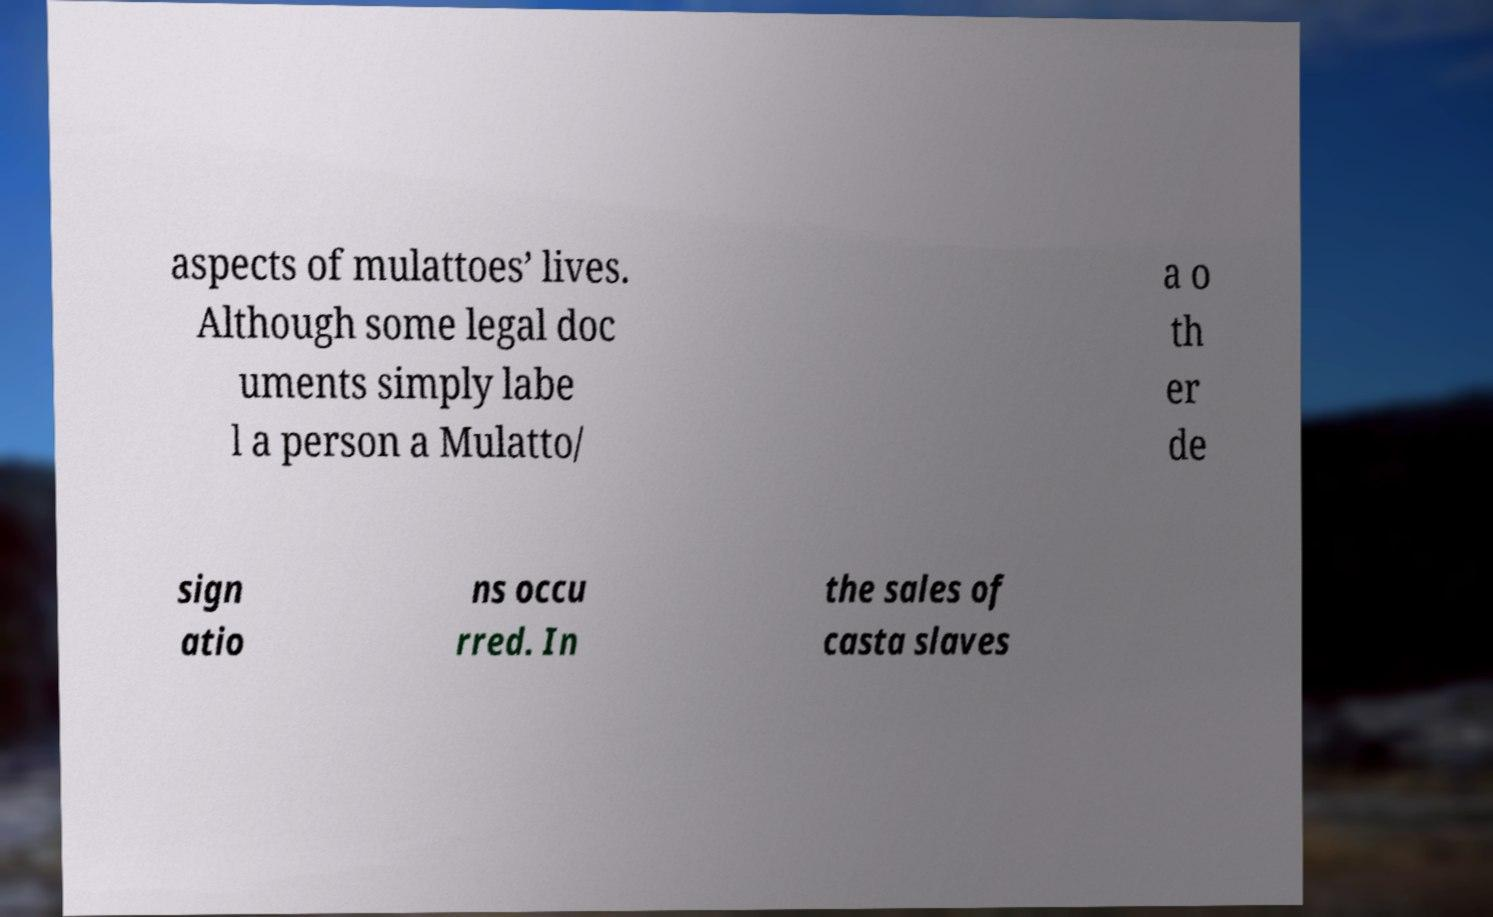What messages or text are displayed in this image? I need them in a readable, typed format. aspects of mulattoes’ lives. Although some legal doc uments simply labe l a person a Mulatto/ a o th er de sign atio ns occu rred. In the sales of casta slaves 